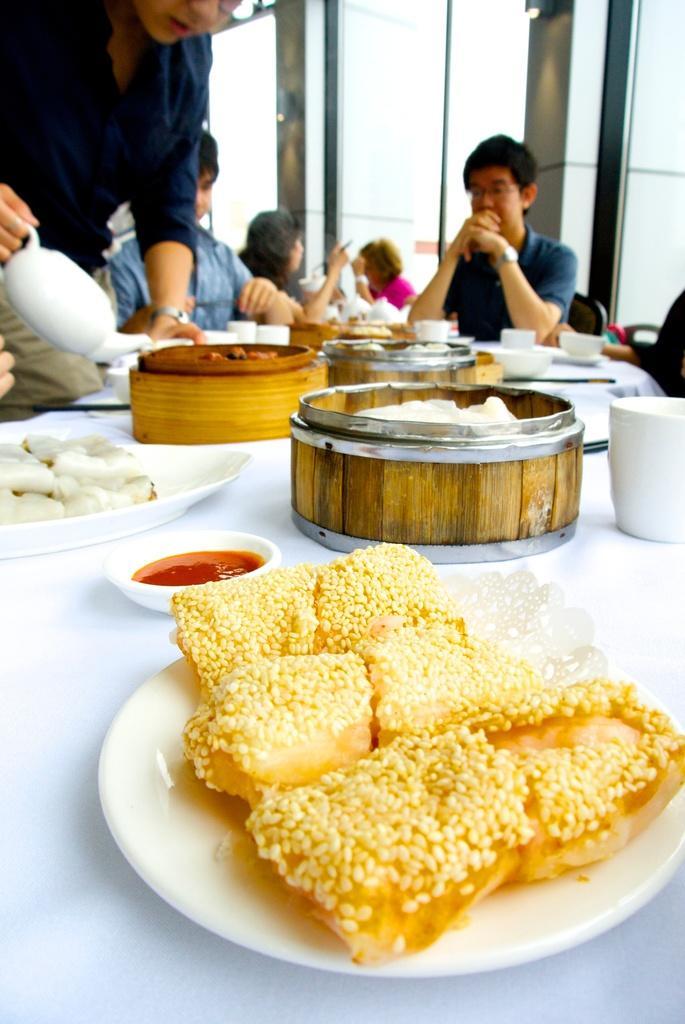Could you give a brief overview of what you see in this image? There are some eatables in boxes and on plates. A man is filling the cup with a kettle. There are few people around the table. 